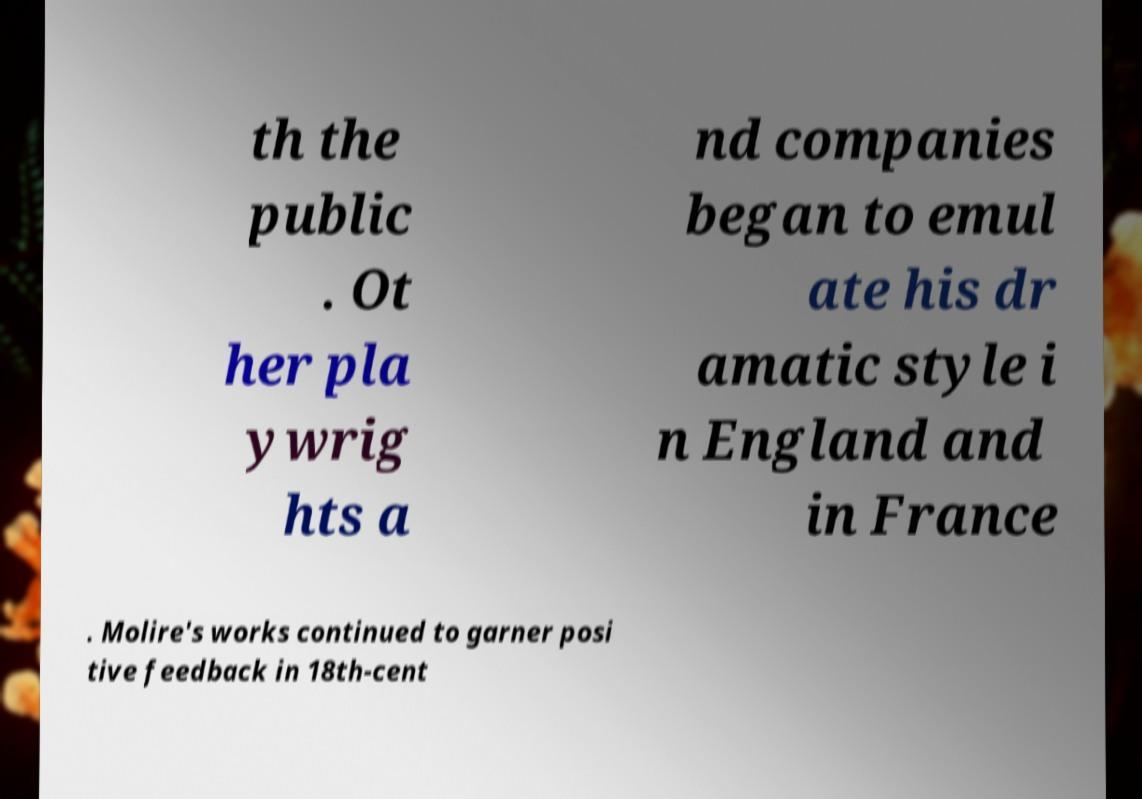Could you assist in decoding the text presented in this image and type it out clearly? th the public . Ot her pla ywrig hts a nd companies began to emul ate his dr amatic style i n England and in France . Molire's works continued to garner posi tive feedback in 18th-cent 